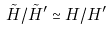Convert formula to latex. <formula><loc_0><loc_0><loc_500><loc_500>\tilde { H } / \tilde { H } ^ { \prime } \simeq H / H ^ { \prime }</formula> 